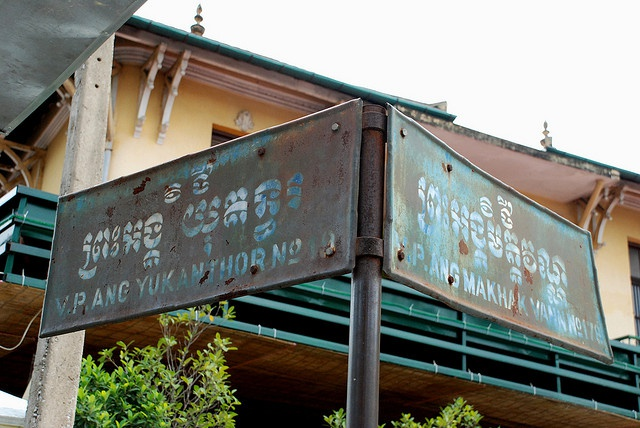Describe the objects in this image and their specific colors. I can see various objects in this image with different colors. 